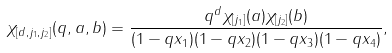<formula> <loc_0><loc_0><loc_500><loc_500>\chi _ { [ d , j _ { 1 } , j _ { 2 } ] } ( q , a , b ) = \frac { q ^ { d } \chi _ { [ j _ { 1 } ] } ( a ) \chi _ { [ j _ { 2 } ] } ( b ) } { ( 1 - q x _ { 1 } ) ( 1 - q x _ { 2 } ) ( 1 - q x _ { 3 } ) ( 1 - q x _ { 4 } ) } ,</formula> 